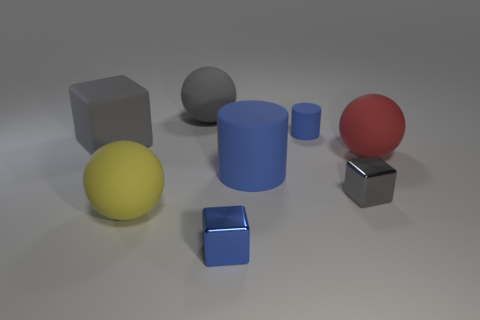Imagine these objects are part of a game, what sort of game could it be? If these objects were part of a game, it could be a physics-based puzzle game. In such a game, the player could be required to stack or arrange the objects according to specific criteria, such as balancing them in a particular way or fitting them into a designated area. The different shapes and materials would add complexity to the game, as the player would need to consider how they interact with each other and their environment. 